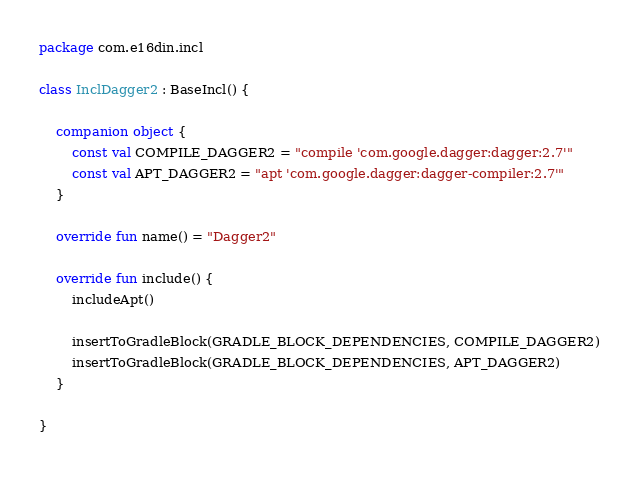Convert code to text. <code><loc_0><loc_0><loc_500><loc_500><_Kotlin_>package com.e16din.incl

class InclDagger2 : BaseIncl() {

    companion object {
        const val COMPILE_DAGGER2 = "compile 'com.google.dagger:dagger:2.7'"
        const val APT_DAGGER2 = "apt 'com.google.dagger:dagger-compiler:2.7'"
    }

    override fun name() = "Dagger2"

    override fun include() {
        includeApt()

        insertToGradleBlock(GRADLE_BLOCK_DEPENDENCIES, COMPILE_DAGGER2)
        insertToGradleBlock(GRADLE_BLOCK_DEPENDENCIES, APT_DAGGER2)
    }

}</code> 